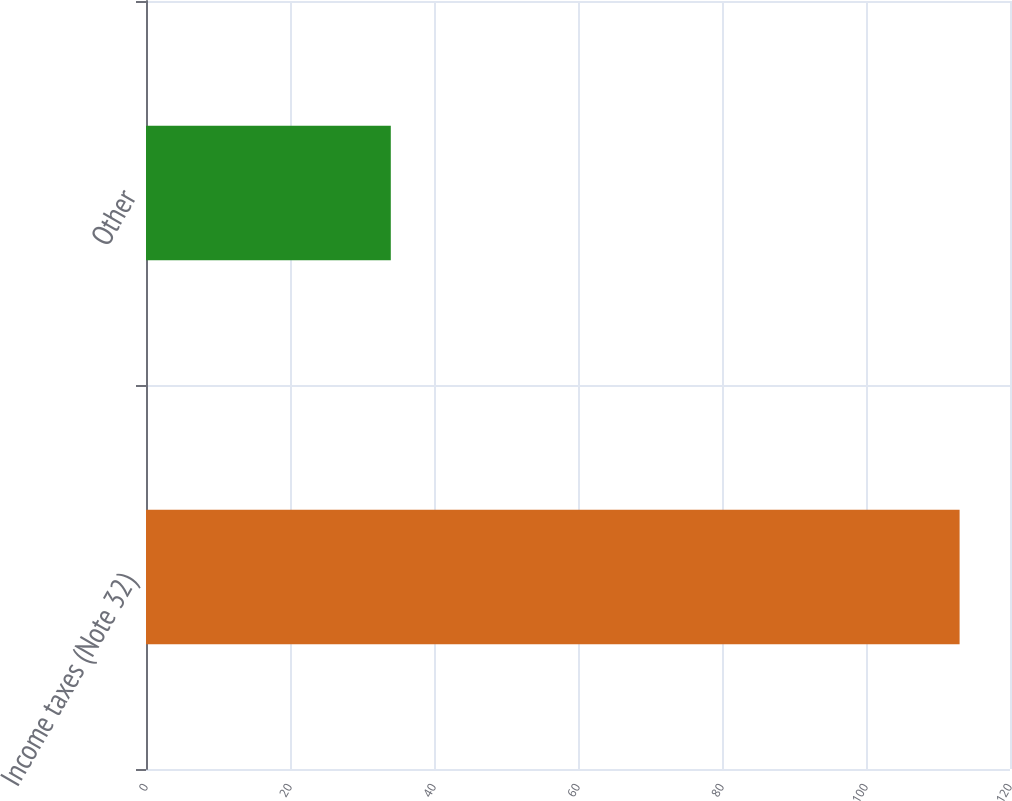Convert chart. <chart><loc_0><loc_0><loc_500><loc_500><bar_chart><fcel>Income taxes (Note 32)<fcel>Other<nl><fcel>113<fcel>34<nl></chart> 